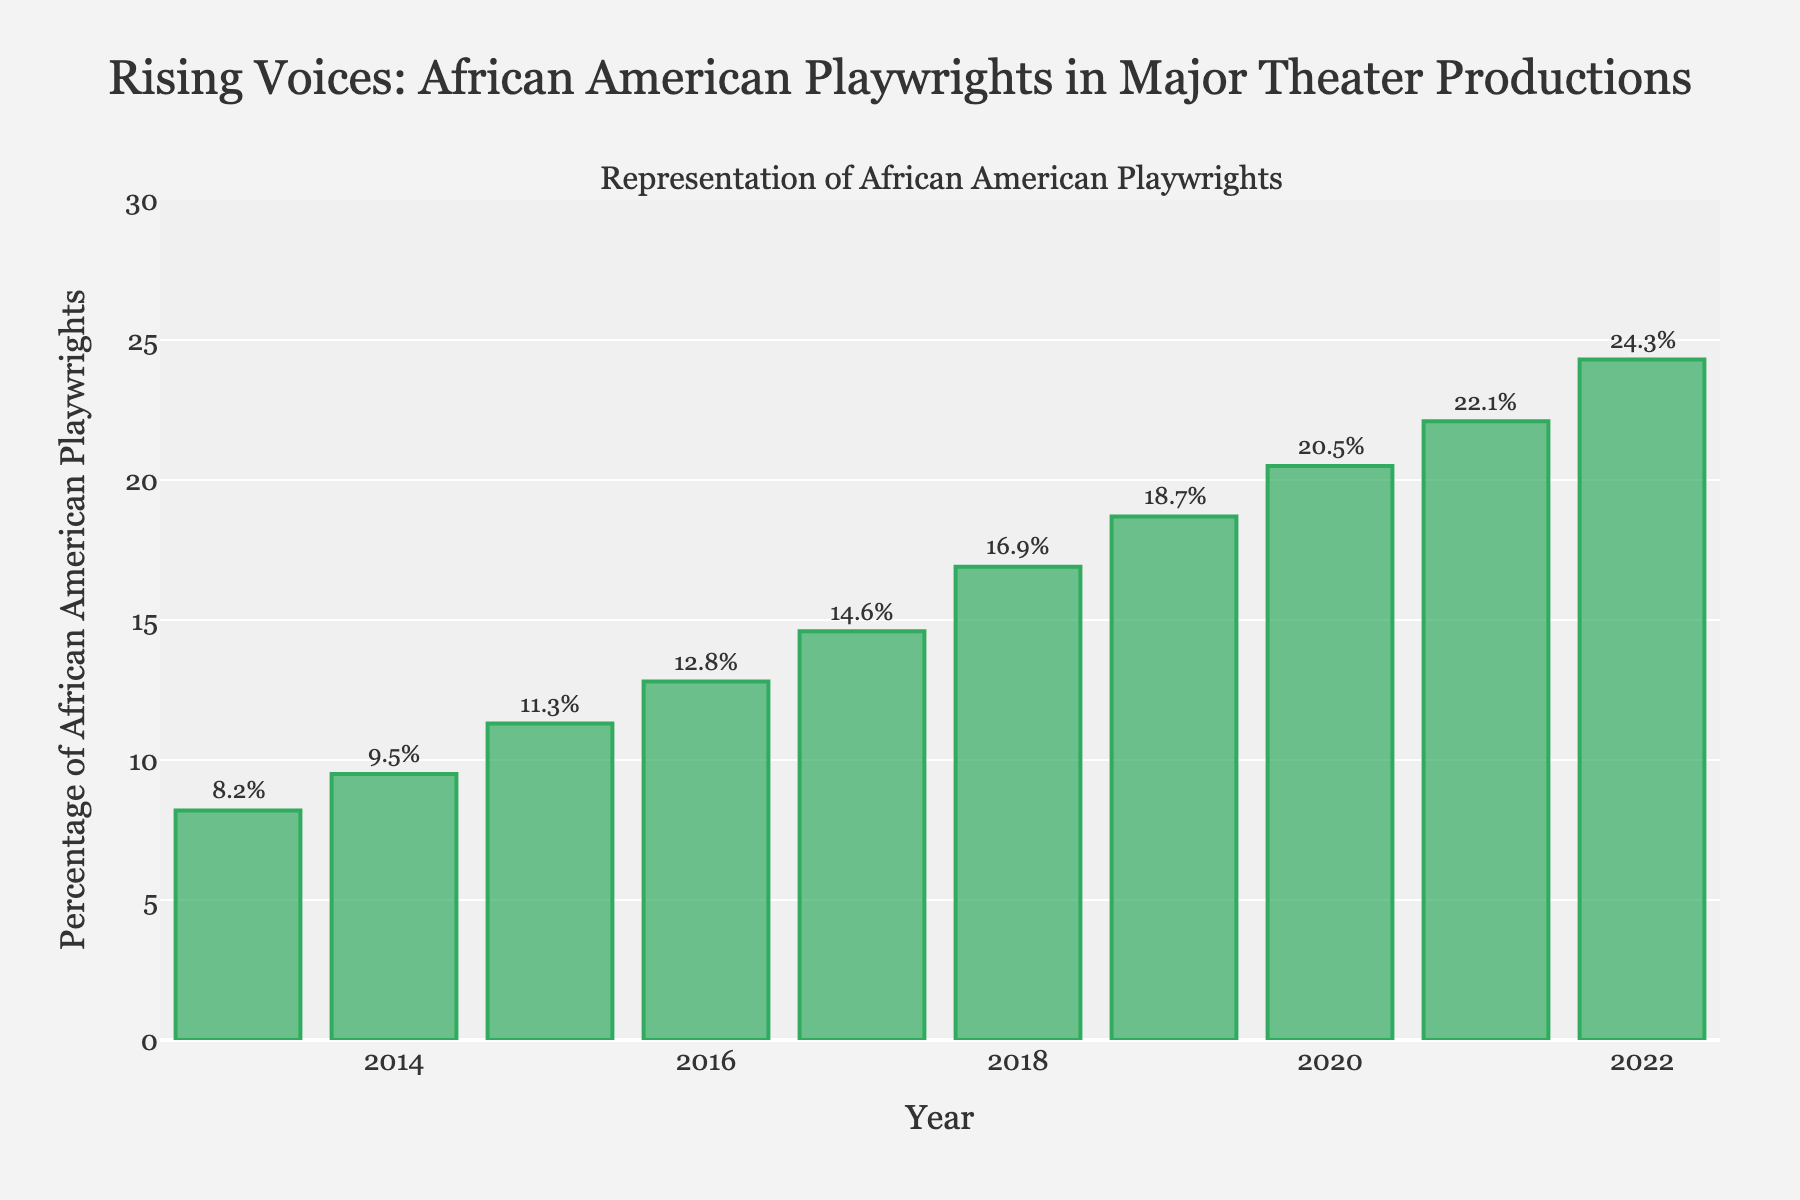What year had the highest percentage of African American playwrights? The highest bar represents the year 2022 with a percentage of 24.3%.
Answer: 2022 Between which consecutive years did the percentage increase the most? To find the largest increase, calculate the differences between consecutive years: 9.5-8.2=1.3, 11.3-9.5=1.8, 12.8-11.3=1.5, 14.6-12.8=1.8, 16.9-14.6=2.3, 18.7-16.9=1.8, 20.5-18.7=1.8, 22.1-20.5=1.6, 24.3-22.1=2.2. The largest increase of 2.3% occurred between 2017 and 2018.
Answer: 2017-2018 What’s the average percentage of African American playwrights over the decade? Sum the percentages and divide by 10: (8.2+9.5+11.3+12.8+14.6+16.9+18.7+20.5+22.1+24.3)/10 ≈ 15.89%.
Answer: 15.89% Which year saw just over a 10% representation of African American playwrights? Check the percentages for each year in the figure: 2015 has a percentage of 11.3%, which is just over 10%.
Answer: 2015 By how much did the percentage increase from 2013 to 2022? Subtract the 2013 percentage from the 2022 percentage: 24.3% - 8.2% = 16.1%.
Answer: 16.1% Was there any year where the percentage did not increase compared to the previous year? Examine the percentages for each year. Every year's percentage is higher than the previous year, indicating a consistent increase.
Answer: No What is the median value of the percentages in the data? Arrange the percentages in order and find the middle value: (8.2, 9.5, 11.3, 12.8, 14.6, 16.9, 18.7, 20.5, 22.1, 24.3). The median is the average of the 5th and 6th values: (14.6 + 16.9)/2 = 15.75%.
Answer: 15.75% What color represents the bars in the chart? The description mentions that the bars are colored in a shade of green.
Answer: Green Which two consecutive years had the smallest increase in percentages? Calculate the differences between consecutive years: 9.5-8.2=1.3, 11.3-9.5=1.8, 12.8-11.3=1.5, 14.6-12.8=1.8, 16.9-14.6=2.3, 18.7-16.9=1.8, 20.5-18.7=1.8, 22.1-20.5=1.6, 24.3-22.1=2.2. The smallest increase of 1.3 occurred between 2013 and 2014.
Answer: 2013-2014 